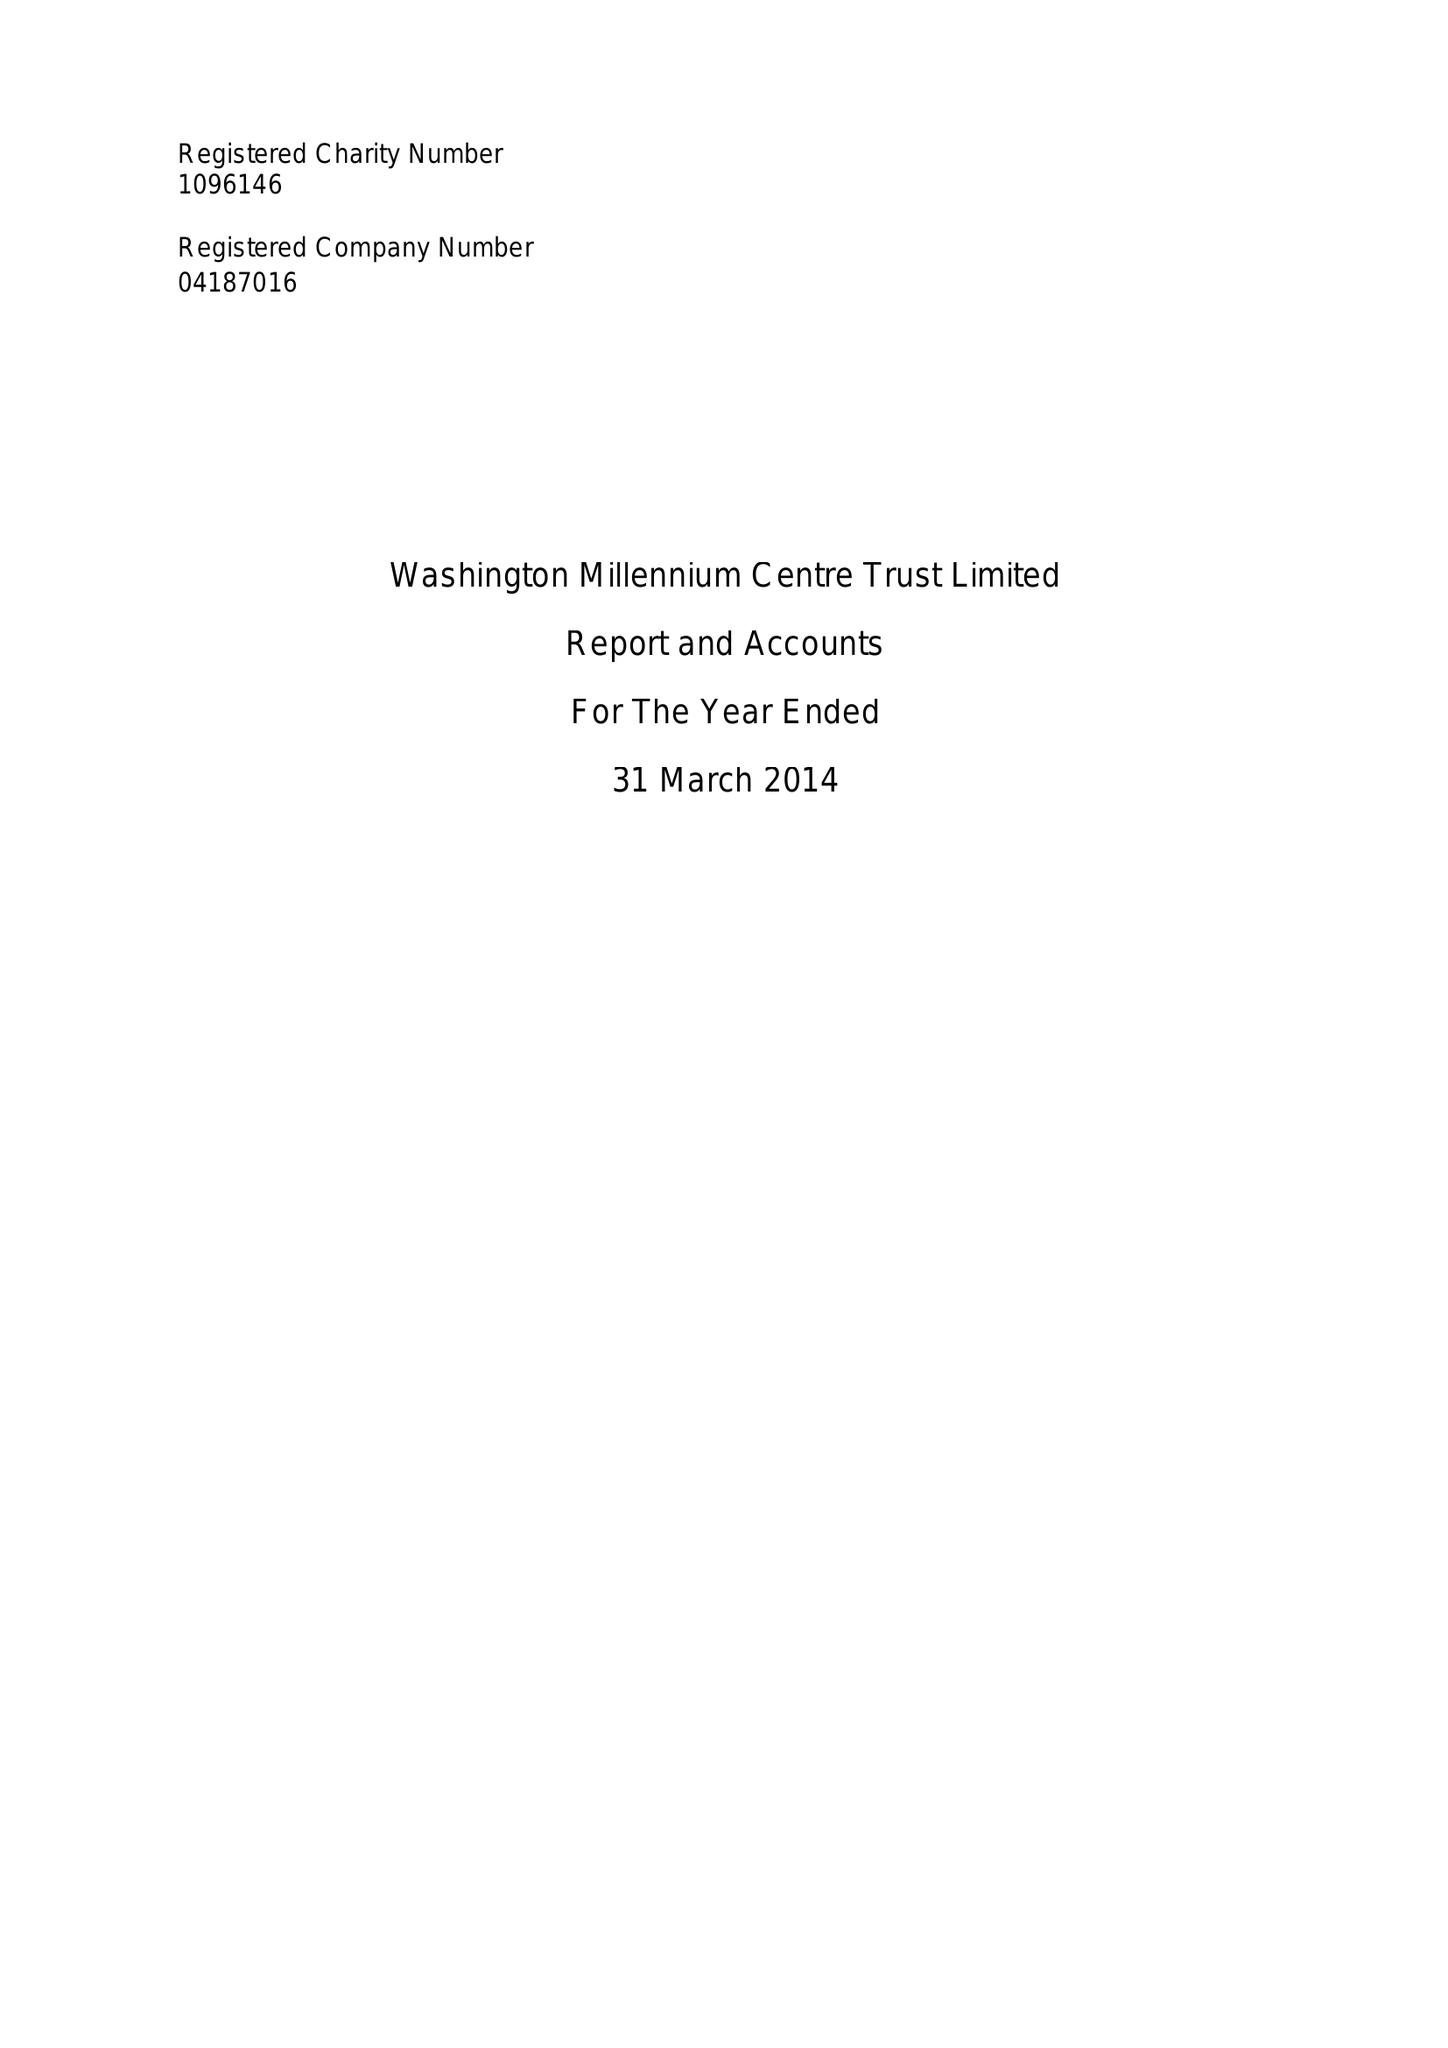What is the value for the charity_number?
Answer the question using a single word or phrase. 1096146 